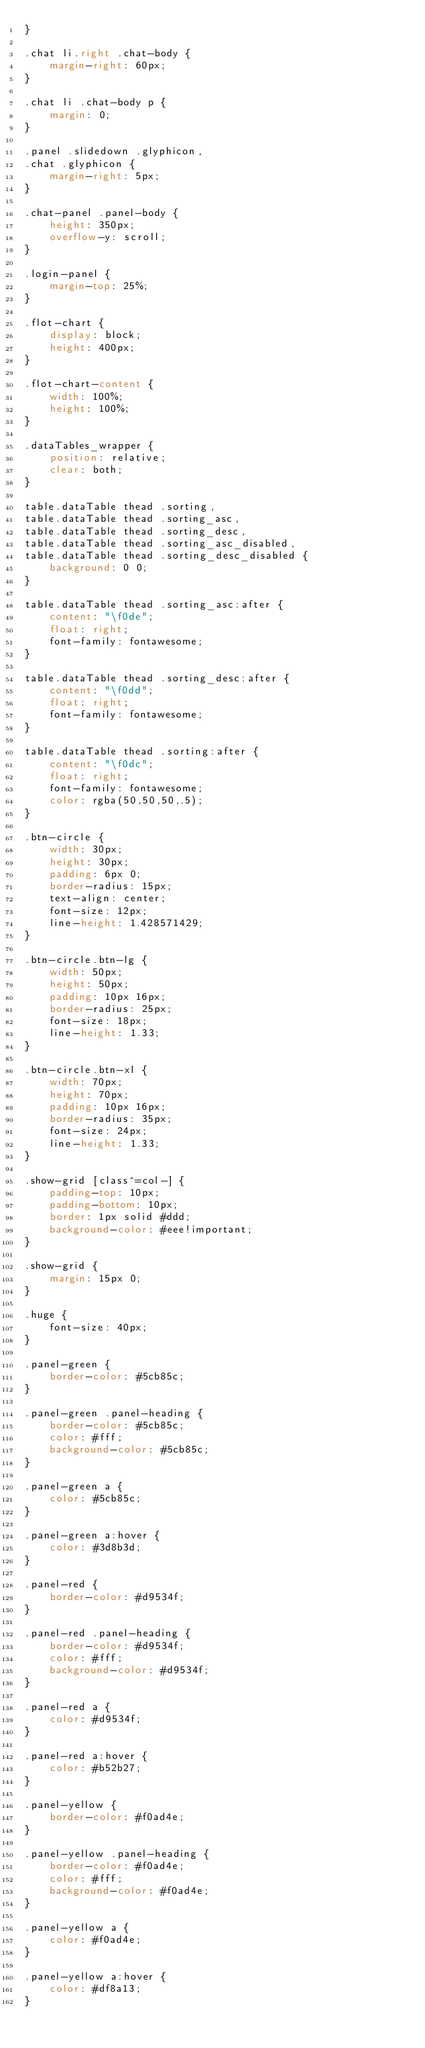<code> <loc_0><loc_0><loc_500><loc_500><_CSS_>}

.chat li.right .chat-body {
    margin-right: 60px;
}

.chat li .chat-body p {
    margin: 0;
}

.panel .slidedown .glyphicon,
.chat .glyphicon {
    margin-right: 5px;
}

.chat-panel .panel-body {
    height: 350px;
    overflow-y: scroll;
}

.login-panel {
    margin-top: 25%;
}

.flot-chart {
    display: block;
    height: 400px;
}

.flot-chart-content {
    width: 100%;
    height: 100%;
}

.dataTables_wrapper {
    position: relative;
    clear: both;
}

table.dataTable thead .sorting,
table.dataTable thead .sorting_asc,
table.dataTable thead .sorting_desc,
table.dataTable thead .sorting_asc_disabled,
table.dataTable thead .sorting_desc_disabled {
    background: 0 0;
}

table.dataTable thead .sorting_asc:after {
    content: "\f0de";
    float: right;
    font-family: fontawesome;
}

table.dataTable thead .sorting_desc:after {
    content: "\f0dd";
    float: right;
    font-family: fontawesome;
}

table.dataTable thead .sorting:after {
    content: "\f0dc";
    float: right;
    font-family: fontawesome;
    color: rgba(50,50,50,.5);
}

.btn-circle {
    width: 30px;
    height: 30px;
    padding: 6px 0;
    border-radius: 15px;
    text-align: center;
    font-size: 12px;
    line-height: 1.428571429;
}

.btn-circle.btn-lg {
    width: 50px;
    height: 50px;
    padding: 10px 16px;
    border-radius: 25px;
    font-size: 18px;
    line-height: 1.33;
}

.btn-circle.btn-xl {
    width: 70px;
    height: 70px;
    padding: 10px 16px;
    border-radius: 35px;
    font-size: 24px;
    line-height: 1.33;
}

.show-grid [class^=col-] {
    padding-top: 10px;
    padding-bottom: 10px;
    border: 1px solid #ddd;
    background-color: #eee!important;
}

.show-grid {
    margin: 15px 0;
}

.huge {
    font-size: 40px;
}

.panel-green {
    border-color: #5cb85c;
}

.panel-green .panel-heading {
    border-color: #5cb85c;
    color: #fff;
    background-color: #5cb85c;
}

.panel-green a {
    color: #5cb85c;
}

.panel-green a:hover {
    color: #3d8b3d;
}

.panel-red {
    border-color: #d9534f;
}

.panel-red .panel-heading {
    border-color: #d9534f;
    color: #fff;
    background-color: #d9534f;
}

.panel-red a {
    color: #d9534f;
}

.panel-red a:hover {
    color: #b52b27;
}

.panel-yellow {
    border-color: #f0ad4e;
}

.panel-yellow .panel-heading {
    border-color: #f0ad4e;
    color: #fff;
    background-color: #f0ad4e;
}

.panel-yellow a {
    color: #f0ad4e;
}

.panel-yellow a:hover {
    color: #df8a13;
}</code> 